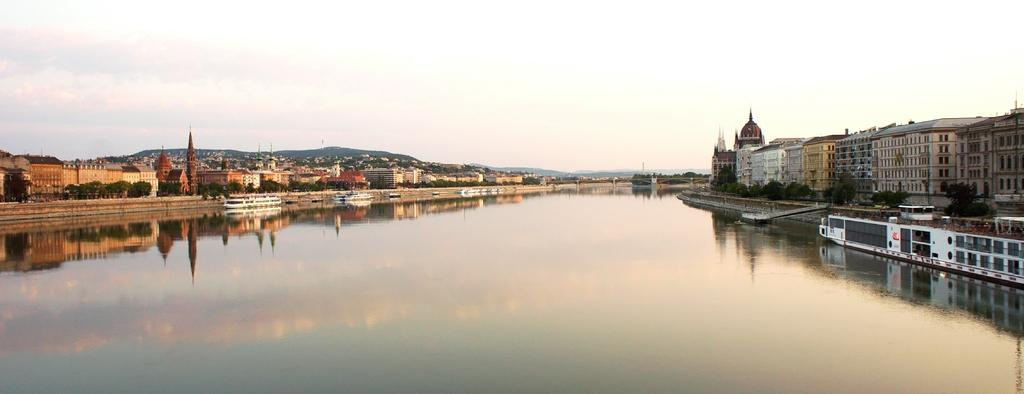What type of natural feature is present in the image? There is a river in the image. How is the river situated in relation to the buildings? The river is between buildings in the image. What can be seen on the right side of the image? There is a boat on the right side of the image. What is visible at the top of the image? The sky is visible at the top of the image. What type of songs are being sung by the earth in the image? There is no reference to songs or the earth in the image; it features a river, buildings, a boat, and the sky. 